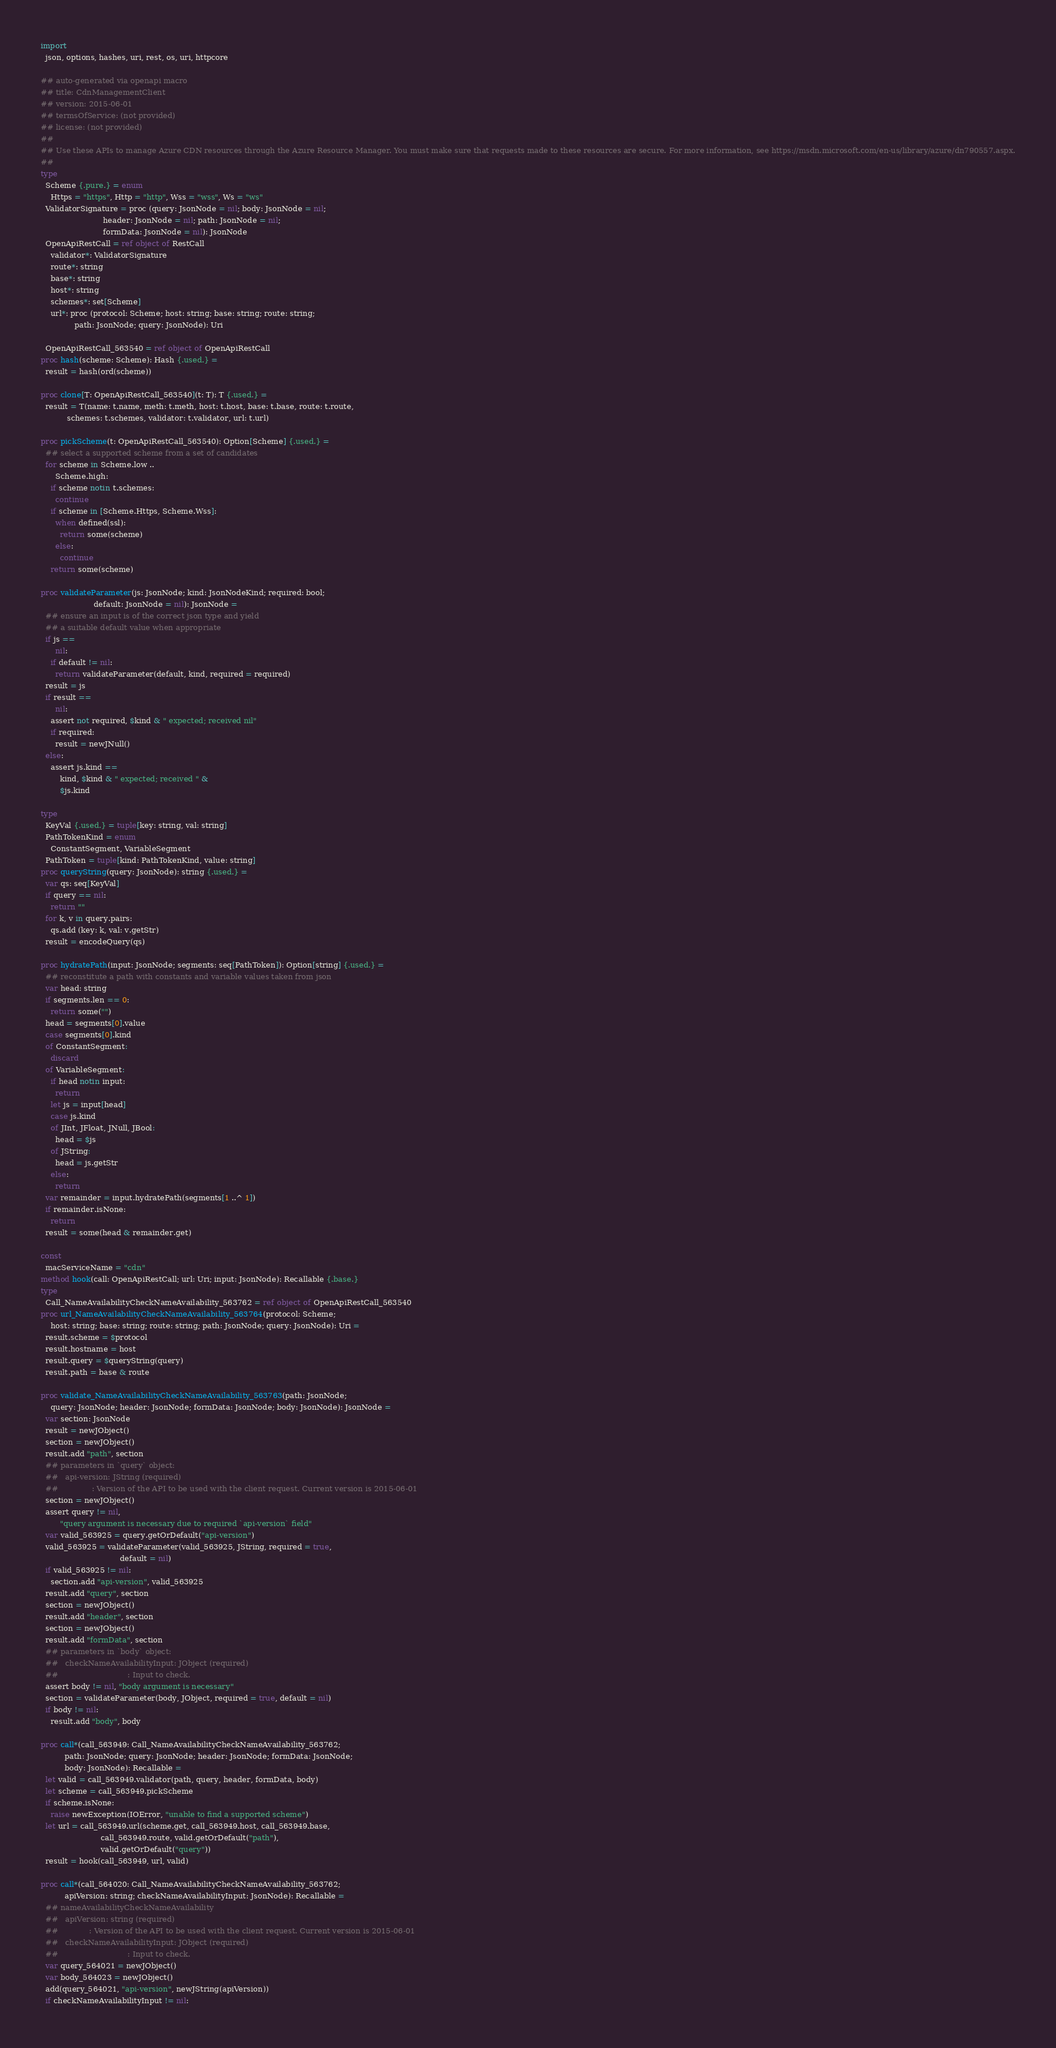<code> <loc_0><loc_0><loc_500><loc_500><_Nim_>
import
  json, options, hashes, uri, rest, os, uri, httpcore

## auto-generated via openapi macro
## title: CdnManagementClient
## version: 2015-06-01
## termsOfService: (not provided)
## license: (not provided)
## 
## Use these APIs to manage Azure CDN resources through the Azure Resource Manager. You must make sure that requests made to these resources are secure. For more information, see https://msdn.microsoft.com/en-us/library/azure/dn790557.aspx.
## 
type
  Scheme {.pure.} = enum
    Https = "https", Http = "http", Wss = "wss", Ws = "ws"
  ValidatorSignature = proc (query: JsonNode = nil; body: JsonNode = nil;
                          header: JsonNode = nil; path: JsonNode = nil;
                          formData: JsonNode = nil): JsonNode
  OpenApiRestCall = ref object of RestCall
    validator*: ValidatorSignature
    route*: string
    base*: string
    host*: string
    schemes*: set[Scheme]
    url*: proc (protocol: Scheme; host: string; base: string; route: string;
              path: JsonNode; query: JsonNode): Uri

  OpenApiRestCall_563540 = ref object of OpenApiRestCall
proc hash(scheme: Scheme): Hash {.used.} =
  result = hash(ord(scheme))

proc clone[T: OpenApiRestCall_563540](t: T): T {.used.} =
  result = T(name: t.name, meth: t.meth, host: t.host, base: t.base, route: t.route,
           schemes: t.schemes, validator: t.validator, url: t.url)

proc pickScheme(t: OpenApiRestCall_563540): Option[Scheme] {.used.} =
  ## select a supported scheme from a set of candidates
  for scheme in Scheme.low ..
      Scheme.high:
    if scheme notin t.schemes:
      continue
    if scheme in [Scheme.Https, Scheme.Wss]:
      when defined(ssl):
        return some(scheme)
      else:
        continue
    return some(scheme)

proc validateParameter(js: JsonNode; kind: JsonNodeKind; required: bool;
                      default: JsonNode = nil): JsonNode =
  ## ensure an input is of the correct json type and yield
  ## a suitable default value when appropriate
  if js ==
      nil:
    if default != nil:
      return validateParameter(default, kind, required = required)
  result = js
  if result ==
      nil:
    assert not required, $kind & " expected; received nil"
    if required:
      result = newJNull()
  else:
    assert js.kind ==
        kind, $kind & " expected; received " &
        $js.kind

type
  KeyVal {.used.} = tuple[key: string, val: string]
  PathTokenKind = enum
    ConstantSegment, VariableSegment
  PathToken = tuple[kind: PathTokenKind, value: string]
proc queryString(query: JsonNode): string {.used.} =
  var qs: seq[KeyVal]
  if query == nil:
    return ""
  for k, v in query.pairs:
    qs.add (key: k, val: v.getStr)
  result = encodeQuery(qs)

proc hydratePath(input: JsonNode; segments: seq[PathToken]): Option[string] {.used.} =
  ## reconstitute a path with constants and variable values taken from json
  var head: string
  if segments.len == 0:
    return some("")
  head = segments[0].value
  case segments[0].kind
  of ConstantSegment:
    discard
  of VariableSegment:
    if head notin input:
      return
    let js = input[head]
    case js.kind
    of JInt, JFloat, JNull, JBool:
      head = $js
    of JString:
      head = js.getStr
    else:
      return
  var remainder = input.hydratePath(segments[1 ..^ 1])
  if remainder.isNone:
    return
  result = some(head & remainder.get)

const
  macServiceName = "cdn"
method hook(call: OpenApiRestCall; url: Uri; input: JsonNode): Recallable {.base.}
type
  Call_NameAvailabilityCheckNameAvailability_563762 = ref object of OpenApiRestCall_563540
proc url_NameAvailabilityCheckNameAvailability_563764(protocol: Scheme;
    host: string; base: string; route: string; path: JsonNode; query: JsonNode): Uri =
  result.scheme = $protocol
  result.hostname = host
  result.query = $queryString(query)
  result.path = base & route

proc validate_NameAvailabilityCheckNameAvailability_563763(path: JsonNode;
    query: JsonNode; header: JsonNode; formData: JsonNode; body: JsonNode): JsonNode =
  var section: JsonNode
  result = newJObject()
  section = newJObject()
  result.add "path", section
  ## parameters in `query` object:
  ##   api-version: JString (required)
  ##              : Version of the API to be used with the client request. Current version is 2015-06-01
  section = newJObject()
  assert query != nil,
        "query argument is necessary due to required `api-version` field"
  var valid_563925 = query.getOrDefault("api-version")
  valid_563925 = validateParameter(valid_563925, JString, required = true,
                                 default = nil)
  if valid_563925 != nil:
    section.add "api-version", valid_563925
  result.add "query", section
  section = newJObject()
  result.add "header", section
  section = newJObject()
  result.add "formData", section
  ## parameters in `body` object:
  ##   checkNameAvailabilityInput: JObject (required)
  ##                             : Input to check.
  assert body != nil, "body argument is necessary"
  section = validateParameter(body, JObject, required = true, default = nil)
  if body != nil:
    result.add "body", body

proc call*(call_563949: Call_NameAvailabilityCheckNameAvailability_563762;
          path: JsonNode; query: JsonNode; header: JsonNode; formData: JsonNode;
          body: JsonNode): Recallable =
  let valid = call_563949.validator(path, query, header, formData, body)
  let scheme = call_563949.pickScheme
  if scheme.isNone:
    raise newException(IOError, "unable to find a supported scheme")
  let url = call_563949.url(scheme.get, call_563949.host, call_563949.base,
                         call_563949.route, valid.getOrDefault("path"),
                         valid.getOrDefault("query"))
  result = hook(call_563949, url, valid)

proc call*(call_564020: Call_NameAvailabilityCheckNameAvailability_563762;
          apiVersion: string; checkNameAvailabilityInput: JsonNode): Recallable =
  ## nameAvailabilityCheckNameAvailability
  ##   apiVersion: string (required)
  ##             : Version of the API to be used with the client request. Current version is 2015-06-01
  ##   checkNameAvailabilityInput: JObject (required)
  ##                             : Input to check.
  var query_564021 = newJObject()
  var body_564023 = newJObject()
  add(query_564021, "api-version", newJString(apiVersion))
  if checkNameAvailabilityInput != nil:</code> 